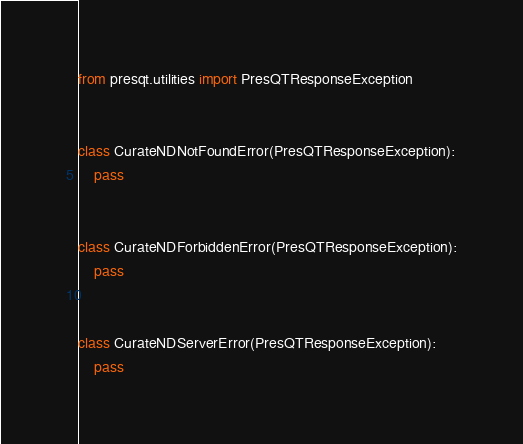Convert code to text. <code><loc_0><loc_0><loc_500><loc_500><_Python_>from presqt.utilities import PresQTResponseException


class CurateNDNotFoundError(PresQTResponseException):
    pass


class CurateNDForbiddenError(PresQTResponseException):
    pass


class CurateNDServerError(PresQTResponseException):
    pass
</code> 